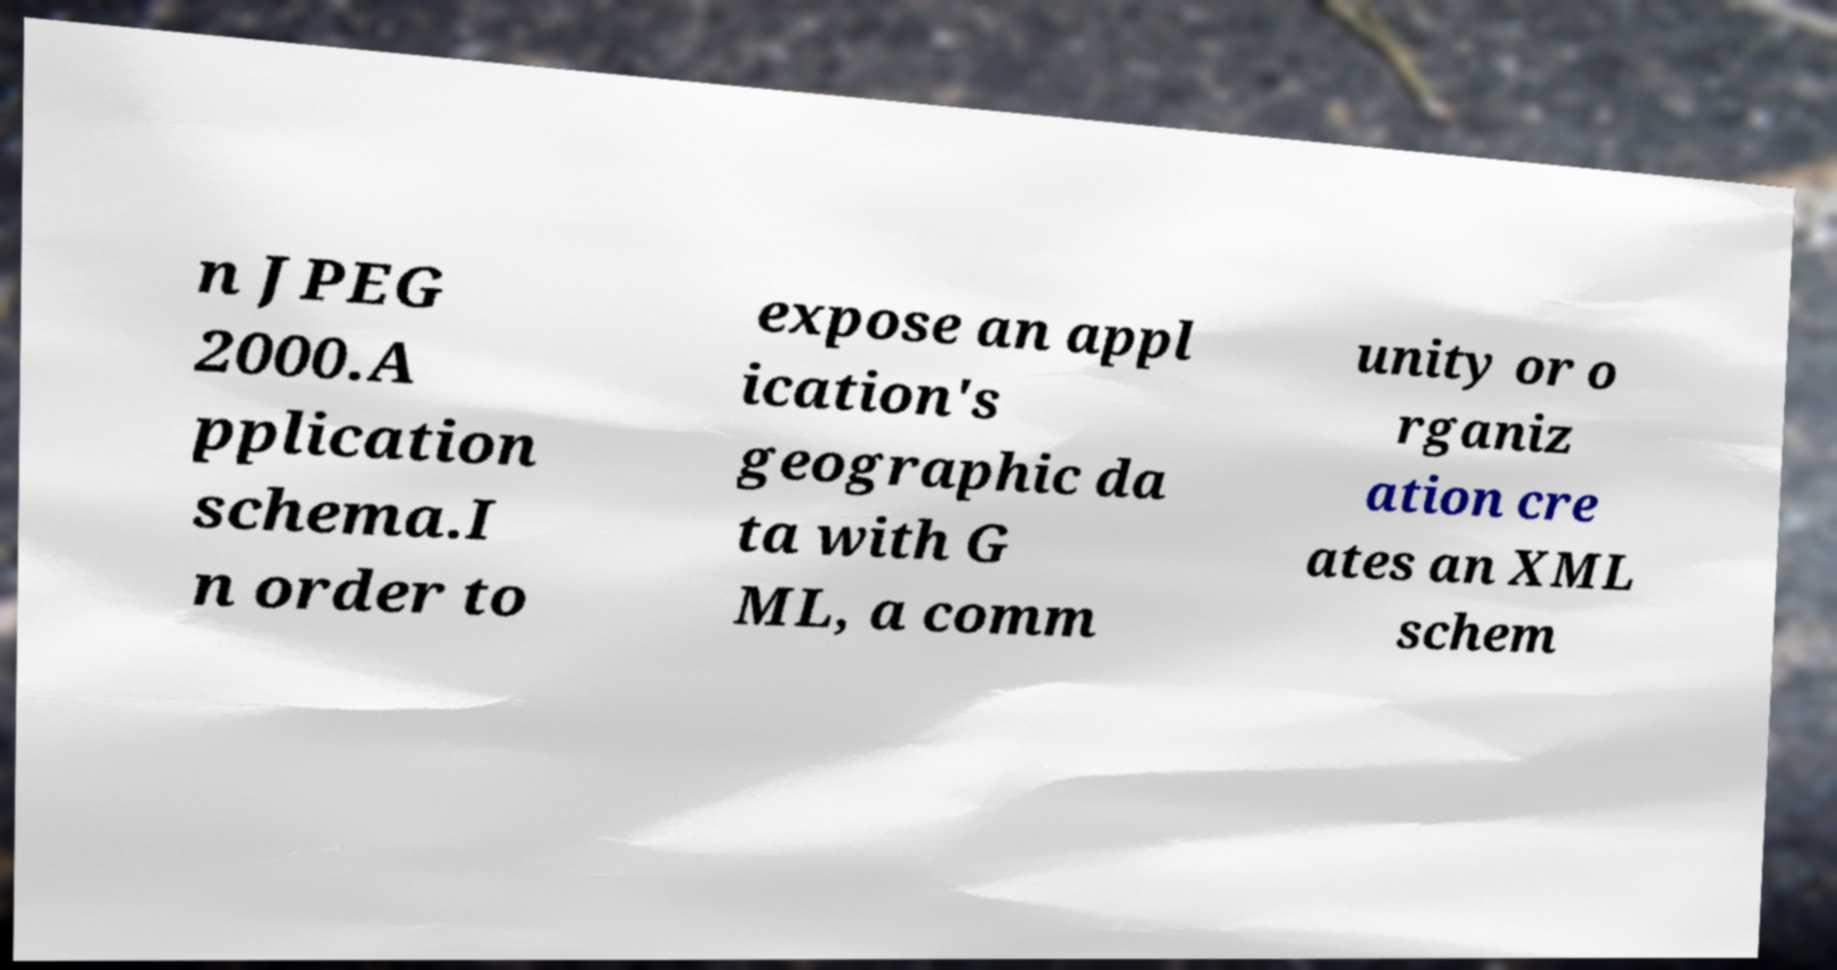I need the written content from this picture converted into text. Can you do that? n JPEG 2000.A pplication schema.I n order to expose an appl ication's geographic da ta with G ML, a comm unity or o rganiz ation cre ates an XML schem 